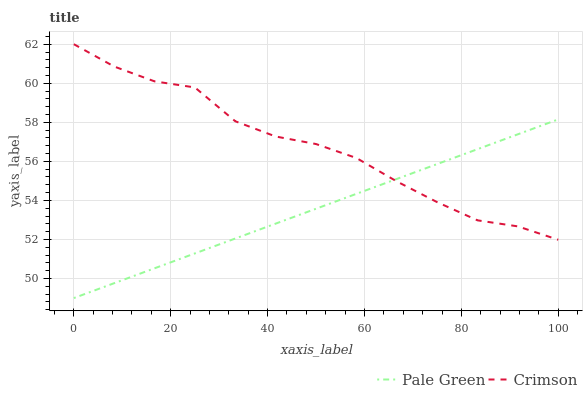Does Pale Green have the minimum area under the curve?
Answer yes or no. Yes. Does Crimson have the maximum area under the curve?
Answer yes or no. Yes. Does Pale Green have the maximum area under the curve?
Answer yes or no. No. Is Pale Green the smoothest?
Answer yes or no. Yes. Is Crimson the roughest?
Answer yes or no. Yes. Is Pale Green the roughest?
Answer yes or no. No. Does Pale Green have the lowest value?
Answer yes or no. Yes. Does Crimson have the highest value?
Answer yes or no. Yes. Does Pale Green have the highest value?
Answer yes or no. No. Does Crimson intersect Pale Green?
Answer yes or no. Yes. Is Crimson less than Pale Green?
Answer yes or no. No. Is Crimson greater than Pale Green?
Answer yes or no. No. 